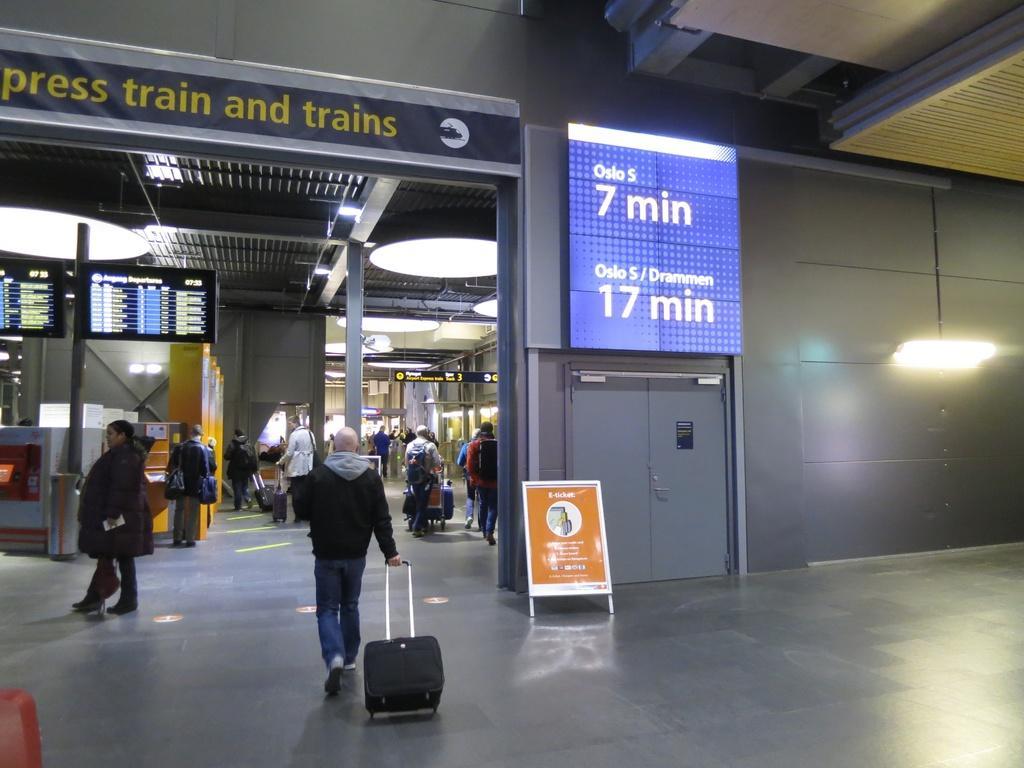Please provide a concise description of this image. In this image in the front there is a person holding a luggage bag and walking. In the center there are persons standing and walking and there are boards with some text and numbers written on it. In the background there are persons, there are birds, there are pillars and lights. 